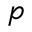Convert formula to latex. <formula><loc_0><loc_0><loc_500><loc_500>p</formula> 